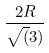Convert formula to latex. <formula><loc_0><loc_0><loc_500><loc_500>\frac { 2 R } { \sqrt { ( } 3 ) }</formula> 